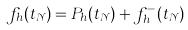<formula> <loc_0><loc_0><loc_500><loc_500>f _ { h } ( t _ { \mathcal { N } } ) = P _ { h } ( t _ { \mathcal { N } } ) + f ^ { - } _ { h } ( t _ { \mathcal { N } } )</formula> 